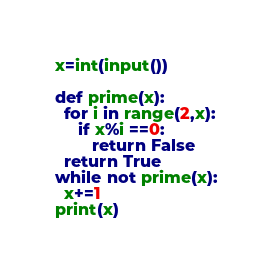Convert code to text. <code><loc_0><loc_0><loc_500><loc_500><_Python_>x=int(input())

def prime(x):
  for i in range(2,x):
     if x%i ==0:
        return False
  return True
while not prime(x):
  x+=1
print(x)</code> 